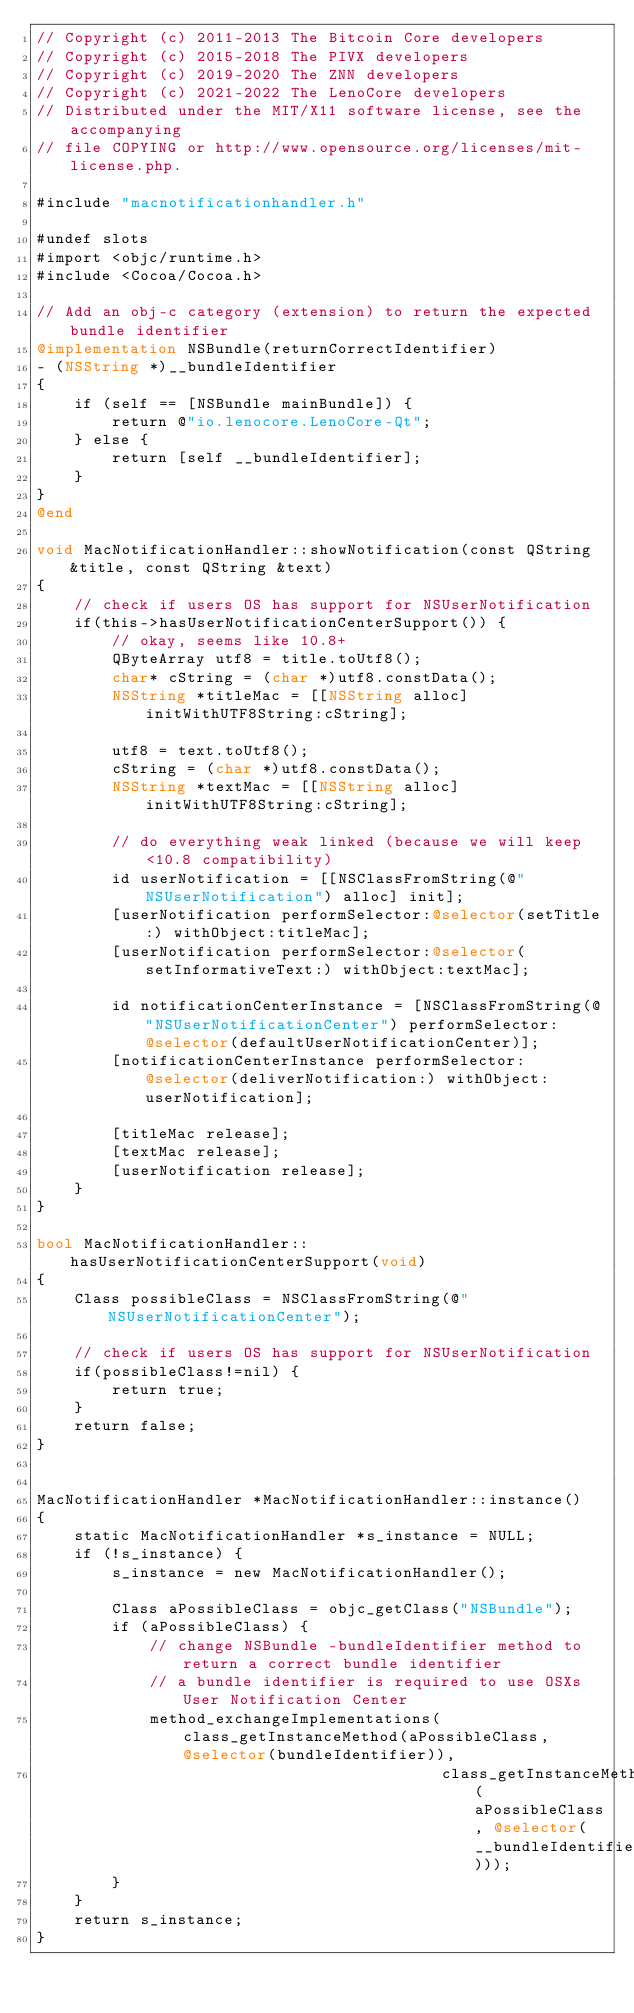<code> <loc_0><loc_0><loc_500><loc_500><_ObjectiveC_>// Copyright (c) 2011-2013 The Bitcoin Core developers
// Copyright (c) 2015-2018 The PIVX developers
// Copyright (c) 2019-2020 The ZNN developers
// Copyright (c) 2021-2022 The LenoCore developers
// Distributed under the MIT/X11 software license, see the accompanying
// file COPYING or http://www.opensource.org/licenses/mit-license.php.

#include "macnotificationhandler.h"

#undef slots
#import <objc/runtime.h>
#include <Cocoa/Cocoa.h>

// Add an obj-c category (extension) to return the expected bundle identifier
@implementation NSBundle(returnCorrectIdentifier)
- (NSString *)__bundleIdentifier
{
    if (self == [NSBundle mainBundle]) {
        return @"io.lenocore.LenoCore-Qt";
    } else {
        return [self __bundleIdentifier];
    }
}
@end

void MacNotificationHandler::showNotification(const QString &title, const QString &text)
{
    // check if users OS has support for NSUserNotification
    if(this->hasUserNotificationCenterSupport()) {
        // okay, seems like 10.8+
        QByteArray utf8 = title.toUtf8();
        char* cString = (char *)utf8.constData();
        NSString *titleMac = [[NSString alloc] initWithUTF8String:cString];

        utf8 = text.toUtf8();
        cString = (char *)utf8.constData();
        NSString *textMac = [[NSString alloc] initWithUTF8String:cString];

        // do everything weak linked (because we will keep <10.8 compatibility)
        id userNotification = [[NSClassFromString(@"NSUserNotification") alloc] init];
        [userNotification performSelector:@selector(setTitle:) withObject:titleMac];
        [userNotification performSelector:@selector(setInformativeText:) withObject:textMac];

        id notificationCenterInstance = [NSClassFromString(@"NSUserNotificationCenter") performSelector:@selector(defaultUserNotificationCenter)];
        [notificationCenterInstance performSelector:@selector(deliverNotification:) withObject:userNotification];

        [titleMac release];
        [textMac release];
        [userNotification release];
    }
}

bool MacNotificationHandler::hasUserNotificationCenterSupport(void)
{
    Class possibleClass = NSClassFromString(@"NSUserNotificationCenter");

    // check if users OS has support for NSUserNotification
    if(possibleClass!=nil) {
        return true;
    }
    return false;
}


MacNotificationHandler *MacNotificationHandler::instance()
{
    static MacNotificationHandler *s_instance = NULL;
    if (!s_instance) {
        s_instance = new MacNotificationHandler();
        
        Class aPossibleClass = objc_getClass("NSBundle");
        if (aPossibleClass) {
            // change NSBundle -bundleIdentifier method to return a correct bundle identifier
            // a bundle identifier is required to use OSXs User Notification Center
            method_exchangeImplementations(class_getInstanceMethod(aPossibleClass, @selector(bundleIdentifier)),
                                           class_getInstanceMethod(aPossibleClass, @selector(__bundleIdentifier)));
        }
    }
    return s_instance;
}
</code> 